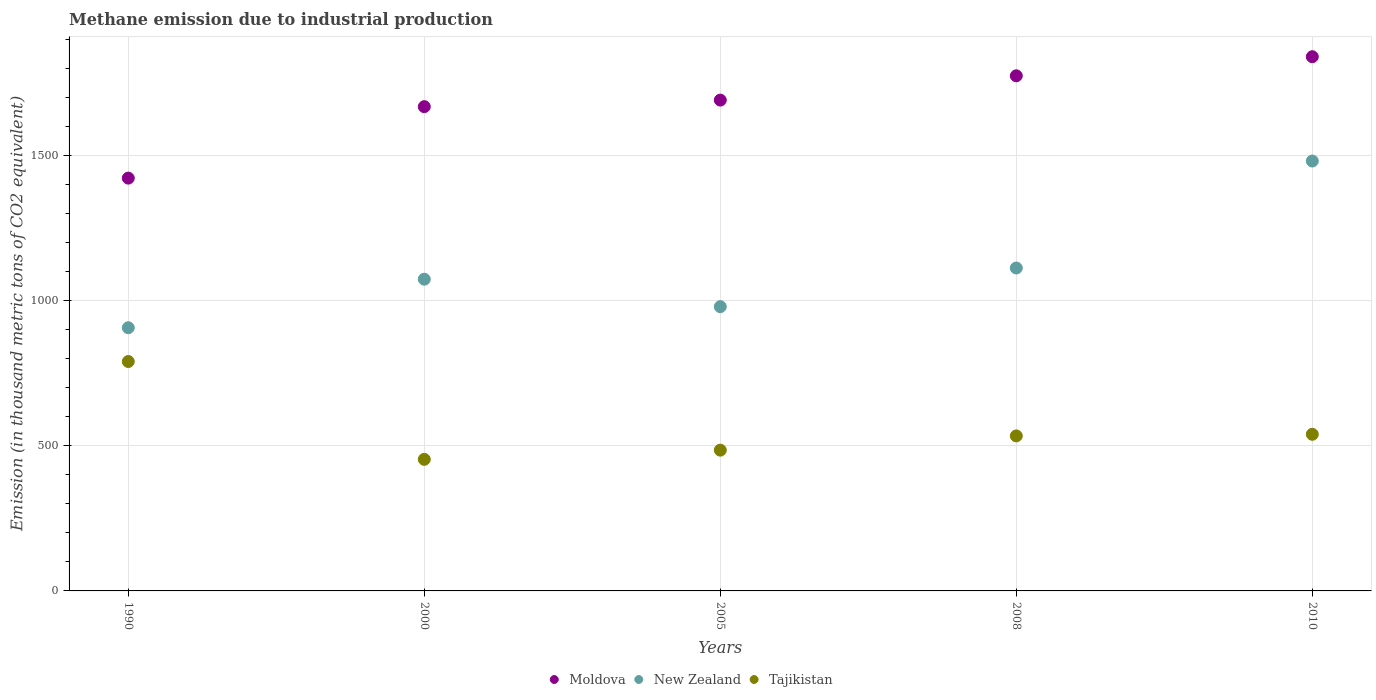How many different coloured dotlines are there?
Offer a very short reply. 3. Is the number of dotlines equal to the number of legend labels?
Keep it short and to the point. Yes. What is the amount of methane emitted in New Zealand in 1990?
Your response must be concise. 906.8. Across all years, what is the maximum amount of methane emitted in Moldova?
Keep it short and to the point. 1840.6. Across all years, what is the minimum amount of methane emitted in Tajikistan?
Offer a very short reply. 453.3. What is the total amount of methane emitted in Tajikistan in the graph?
Offer a very short reply. 2802.5. What is the difference between the amount of methane emitted in Tajikistan in 2005 and that in 2008?
Keep it short and to the point. -49.1. What is the difference between the amount of methane emitted in Moldova in 1990 and the amount of methane emitted in Tajikistan in 2010?
Your response must be concise. 882.6. What is the average amount of methane emitted in Moldova per year?
Keep it short and to the point. 1679.46. In the year 2005, what is the difference between the amount of methane emitted in Moldova and amount of methane emitted in Tajikistan?
Give a very brief answer. 1206.1. What is the ratio of the amount of methane emitted in Tajikistan in 2005 to that in 2010?
Provide a succinct answer. 0.9. Is the amount of methane emitted in Moldova in 2000 less than that in 2008?
Your response must be concise. Yes. Is the difference between the amount of methane emitted in Moldova in 2000 and 2010 greater than the difference between the amount of methane emitted in Tajikistan in 2000 and 2010?
Ensure brevity in your answer.  No. What is the difference between the highest and the second highest amount of methane emitted in New Zealand?
Your answer should be very brief. 368.6. What is the difference between the highest and the lowest amount of methane emitted in Moldova?
Ensure brevity in your answer.  418.3. Is the sum of the amount of methane emitted in New Zealand in 1990 and 2005 greater than the maximum amount of methane emitted in Tajikistan across all years?
Your answer should be very brief. Yes. Is the amount of methane emitted in New Zealand strictly greater than the amount of methane emitted in Moldova over the years?
Your answer should be compact. No. Is the amount of methane emitted in Moldova strictly less than the amount of methane emitted in New Zealand over the years?
Your answer should be compact. No. How many dotlines are there?
Make the answer very short. 3. How many years are there in the graph?
Keep it short and to the point. 5. What is the difference between two consecutive major ticks on the Y-axis?
Provide a succinct answer. 500. Where does the legend appear in the graph?
Offer a very short reply. Bottom center. How many legend labels are there?
Offer a very short reply. 3. How are the legend labels stacked?
Your answer should be compact. Horizontal. What is the title of the graph?
Your answer should be compact. Methane emission due to industrial production. Does "Libya" appear as one of the legend labels in the graph?
Your answer should be very brief. No. What is the label or title of the Y-axis?
Ensure brevity in your answer.  Emission (in thousand metric tons of CO2 equivalent). What is the Emission (in thousand metric tons of CO2 equivalent) in Moldova in 1990?
Your answer should be very brief. 1422.3. What is the Emission (in thousand metric tons of CO2 equivalent) of New Zealand in 1990?
Your answer should be very brief. 906.8. What is the Emission (in thousand metric tons of CO2 equivalent) in Tajikistan in 1990?
Give a very brief answer. 790.4. What is the Emission (in thousand metric tons of CO2 equivalent) of Moldova in 2000?
Offer a terse response. 1668.5. What is the Emission (in thousand metric tons of CO2 equivalent) in New Zealand in 2000?
Make the answer very short. 1074. What is the Emission (in thousand metric tons of CO2 equivalent) of Tajikistan in 2000?
Ensure brevity in your answer.  453.3. What is the Emission (in thousand metric tons of CO2 equivalent) of Moldova in 2005?
Your answer should be compact. 1691.1. What is the Emission (in thousand metric tons of CO2 equivalent) of New Zealand in 2005?
Make the answer very short. 979.4. What is the Emission (in thousand metric tons of CO2 equivalent) in Tajikistan in 2005?
Your response must be concise. 485. What is the Emission (in thousand metric tons of CO2 equivalent) of Moldova in 2008?
Provide a short and direct response. 1774.8. What is the Emission (in thousand metric tons of CO2 equivalent) in New Zealand in 2008?
Provide a succinct answer. 1112.6. What is the Emission (in thousand metric tons of CO2 equivalent) in Tajikistan in 2008?
Provide a succinct answer. 534.1. What is the Emission (in thousand metric tons of CO2 equivalent) of Moldova in 2010?
Give a very brief answer. 1840.6. What is the Emission (in thousand metric tons of CO2 equivalent) in New Zealand in 2010?
Offer a terse response. 1481.2. What is the Emission (in thousand metric tons of CO2 equivalent) in Tajikistan in 2010?
Make the answer very short. 539.7. Across all years, what is the maximum Emission (in thousand metric tons of CO2 equivalent) of Moldova?
Provide a succinct answer. 1840.6. Across all years, what is the maximum Emission (in thousand metric tons of CO2 equivalent) in New Zealand?
Your response must be concise. 1481.2. Across all years, what is the maximum Emission (in thousand metric tons of CO2 equivalent) in Tajikistan?
Provide a short and direct response. 790.4. Across all years, what is the minimum Emission (in thousand metric tons of CO2 equivalent) in Moldova?
Give a very brief answer. 1422.3. Across all years, what is the minimum Emission (in thousand metric tons of CO2 equivalent) of New Zealand?
Make the answer very short. 906.8. Across all years, what is the minimum Emission (in thousand metric tons of CO2 equivalent) of Tajikistan?
Your answer should be compact. 453.3. What is the total Emission (in thousand metric tons of CO2 equivalent) in Moldova in the graph?
Offer a terse response. 8397.3. What is the total Emission (in thousand metric tons of CO2 equivalent) of New Zealand in the graph?
Your response must be concise. 5554. What is the total Emission (in thousand metric tons of CO2 equivalent) in Tajikistan in the graph?
Keep it short and to the point. 2802.5. What is the difference between the Emission (in thousand metric tons of CO2 equivalent) of Moldova in 1990 and that in 2000?
Give a very brief answer. -246.2. What is the difference between the Emission (in thousand metric tons of CO2 equivalent) of New Zealand in 1990 and that in 2000?
Provide a succinct answer. -167.2. What is the difference between the Emission (in thousand metric tons of CO2 equivalent) of Tajikistan in 1990 and that in 2000?
Your answer should be very brief. 337.1. What is the difference between the Emission (in thousand metric tons of CO2 equivalent) in Moldova in 1990 and that in 2005?
Keep it short and to the point. -268.8. What is the difference between the Emission (in thousand metric tons of CO2 equivalent) in New Zealand in 1990 and that in 2005?
Keep it short and to the point. -72.6. What is the difference between the Emission (in thousand metric tons of CO2 equivalent) in Tajikistan in 1990 and that in 2005?
Make the answer very short. 305.4. What is the difference between the Emission (in thousand metric tons of CO2 equivalent) in Moldova in 1990 and that in 2008?
Ensure brevity in your answer.  -352.5. What is the difference between the Emission (in thousand metric tons of CO2 equivalent) of New Zealand in 1990 and that in 2008?
Offer a very short reply. -205.8. What is the difference between the Emission (in thousand metric tons of CO2 equivalent) in Tajikistan in 1990 and that in 2008?
Provide a succinct answer. 256.3. What is the difference between the Emission (in thousand metric tons of CO2 equivalent) in Moldova in 1990 and that in 2010?
Give a very brief answer. -418.3. What is the difference between the Emission (in thousand metric tons of CO2 equivalent) of New Zealand in 1990 and that in 2010?
Ensure brevity in your answer.  -574.4. What is the difference between the Emission (in thousand metric tons of CO2 equivalent) in Tajikistan in 1990 and that in 2010?
Offer a terse response. 250.7. What is the difference between the Emission (in thousand metric tons of CO2 equivalent) of Moldova in 2000 and that in 2005?
Ensure brevity in your answer.  -22.6. What is the difference between the Emission (in thousand metric tons of CO2 equivalent) in New Zealand in 2000 and that in 2005?
Your answer should be very brief. 94.6. What is the difference between the Emission (in thousand metric tons of CO2 equivalent) of Tajikistan in 2000 and that in 2005?
Offer a terse response. -31.7. What is the difference between the Emission (in thousand metric tons of CO2 equivalent) in Moldova in 2000 and that in 2008?
Give a very brief answer. -106.3. What is the difference between the Emission (in thousand metric tons of CO2 equivalent) of New Zealand in 2000 and that in 2008?
Provide a short and direct response. -38.6. What is the difference between the Emission (in thousand metric tons of CO2 equivalent) of Tajikistan in 2000 and that in 2008?
Your answer should be very brief. -80.8. What is the difference between the Emission (in thousand metric tons of CO2 equivalent) in Moldova in 2000 and that in 2010?
Ensure brevity in your answer.  -172.1. What is the difference between the Emission (in thousand metric tons of CO2 equivalent) in New Zealand in 2000 and that in 2010?
Your answer should be compact. -407.2. What is the difference between the Emission (in thousand metric tons of CO2 equivalent) in Tajikistan in 2000 and that in 2010?
Offer a terse response. -86.4. What is the difference between the Emission (in thousand metric tons of CO2 equivalent) in Moldova in 2005 and that in 2008?
Provide a succinct answer. -83.7. What is the difference between the Emission (in thousand metric tons of CO2 equivalent) in New Zealand in 2005 and that in 2008?
Keep it short and to the point. -133.2. What is the difference between the Emission (in thousand metric tons of CO2 equivalent) of Tajikistan in 2005 and that in 2008?
Your answer should be very brief. -49.1. What is the difference between the Emission (in thousand metric tons of CO2 equivalent) of Moldova in 2005 and that in 2010?
Keep it short and to the point. -149.5. What is the difference between the Emission (in thousand metric tons of CO2 equivalent) of New Zealand in 2005 and that in 2010?
Your answer should be very brief. -501.8. What is the difference between the Emission (in thousand metric tons of CO2 equivalent) of Tajikistan in 2005 and that in 2010?
Offer a terse response. -54.7. What is the difference between the Emission (in thousand metric tons of CO2 equivalent) in Moldova in 2008 and that in 2010?
Provide a short and direct response. -65.8. What is the difference between the Emission (in thousand metric tons of CO2 equivalent) in New Zealand in 2008 and that in 2010?
Your answer should be compact. -368.6. What is the difference between the Emission (in thousand metric tons of CO2 equivalent) in Moldova in 1990 and the Emission (in thousand metric tons of CO2 equivalent) in New Zealand in 2000?
Your response must be concise. 348.3. What is the difference between the Emission (in thousand metric tons of CO2 equivalent) of Moldova in 1990 and the Emission (in thousand metric tons of CO2 equivalent) of Tajikistan in 2000?
Give a very brief answer. 969. What is the difference between the Emission (in thousand metric tons of CO2 equivalent) in New Zealand in 1990 and the Emission (in thousand metric tons of CO2 equivalent) in Tajikistan in 2000?
Make the answer very short. 453.5. What is the difference between the Emission (in thousand metric tons of CO2 equivalent) in Moldova in 1990 and the Emission (in thousand metric tons of CO2 equivalent) in New Zealand in 2005?
Offer a very short reply. 442.9. What is the difference between the Emission (in thousand metric tons of CO2 equivalent) in Moldova in 1990 and the Emission (in thousand metric tons of CO2 equivalent) in Tajikistan in 2005?
Offer a terse response. 937.3. What is the difference between the Emission (in thousand metric tons of CO2 equivalent) of New Zealand in 1990 and the Emission (in thousand metric tons of CO2 equivalent) of Tajikistan in 2005?
Keep it short and to the point. 421.8. What is the difference between the Emission (in thousand metric tons of CO2 equivalent) of Moldova in 1990 and the Emission (in thousand metric tons of CO2 equivalent) of New Zealand in 2008?
Make the answer very short. 309.7. What is the difference between the Emission (in thousand metric tons of CO2 equivalent) of Moldova in 1990 and the Emission (in thousand metric tons of CO2 equivalent) of Tajikistan in 2008?
Give a very brief answer. 888.2. What is the difference between the Emission (in thousand metric tons of CO2 equivalent) of New Zealand in 1990 and the Emission (in thousand metric tons of CO2 equivalent) of Tajikistan in 2008?
Keep it short and to the point. 372.7. What is the difference between the Emission (in thousand metric tons of CO2 equivalent) of Moldova in 1990 and the Emission (in thousand metric tons of CO2 equivalent) of New Zealand in 2010?
Your response must be concise. -58.9. What is the difference between the Emission (in thousand metric tons of CO2 equivalent) of Moldova in 1990 and the Emission (in thousand metric tons of CO2 equivalent) of Tajikistan in 2010?
Offer a terse response. 882.6. What is the difference between the Emission (in thousand metric tons of CO2 equivalent) in New Zealand in 1990 and the Emission (in thousand metric tons of CO2 equivalent) in Tajikistan in 2010?
Offer a terse response. 367.1. What is the difference between the Emission (in thousand metric tons of CO2 equivalent) of Moldova in 2000 and the Emission (in thousand metric tons of CO2 equivalent) of New Zealand in 2005?
Provide a succinct answer. 689.1. What is the difference between the Emission (in thousand metric tons of CO2 equivalent) of Moldova in 2000 and the Emission (in thousand metric tons of CO2 equivalent) of Tajikistan in 2005?
Your answer should be very brief. 1183.5. What is the difference between the Emission (in thousand metric tons of CO2 equivalent) of New Zealand in 2000 and the Emission (in thousand metric tons of CO2 equivalent) of Tajikistan in 2005?
Keep it short and to the point. 589. What is the difference between the Emission (in thousand metric tons of CO2 equivalent) of Moldova in 2000 and the Emission (in thousand metric tons of CO2 equivalent) of New Zealand in 2008?
Ensure brevity in your answer.  555.9. What is the difference between the Emission (in thousand metric tons of CO2 equivalent) of Moldova in 2000 and the Emission (in thousand metric tons of CO2 equivalent) of Tajikistan in 2008?
Your response must be concise. 1134.4. What is the difference between the Emission (in thousand metric tons of CO2 equivalent) of New Zealand in 2000 and the Emission (in thousand metric tons of CO2 equivalent) of Tajikistan in 2008?
Offer a very short reply. 539.9. What is the difference between the Emission (in thousand metric tons of CO2 equivalent) in Moldova in 2000 and the Emission (in thousand metric tons of CO2 equivalent) in New Zealand in 2010?
Your answer should be compact. 187.3. What is the difference between the Emission (in thousand metric tons of CO2 equivalent) in Moldova in 2000 and the Emission (in thousand metric tons of CO2 equivalent) in Tajikistan in 2010?
Make the answer very short. 1128.8. What is the difference between the Emission (in thousand metric tons of CO2 equivalent) of New Zealand in 2000 and the Emission (in thousand metric tons of CO2 equivalent) of Tajikistan in 2010?
Offer a very short reply. 534.3. What is the difference between the Emission (in thousand metric tons of CO2 equivalent) of Moldova in 2005 and the Emission (in thousand metric tons of CO2 equivalent) of New Zealand in 2008?
Offer a terse response. 578.5. What is the difference between the Emission (in thousand metric tons of CO2 equivalent) in Moldova in 2005 and the Emission (in thousand metric tons of CO2 equivalent) in Tajikistan in 2008?
Give a very brief answer. 1157. What is the difference between the Emission (in thousand metric tons of CO2 equivalent) in New Zealand in 2005 and the Emission (in thousand metric tons of CO2 equivalent) in Tajikistan in 2008?
Ensure brevity in your answer.  445.3. What is the difference between the Emission (in thousand metric tons of CO2 equivalent) of Moldova in 2005 and the Emission (in thousand metric tons of CO2 equivalent) of New Zealand in 2010?
Provide a succinct answer. 209.9. What is the difference between the Emission (in thousand metric tons of CO2 equivalent) of Moldova in 2005 and the Emission (in thousand metric tons of CO2 equivalent) of Tajikistan in 2010?
Provide a succinct answer. 1151.4. What is the difference between the Emission (in thousand metric tons of CO2 equivalent) of New Zealand in 2005 and the Emission (in thousand metric tons of CO2 equivalent) of Tajikistan in 2010?
Your response must be concise. 439.7. What is the difference between the Emission (in thousand metric tons of CO2 equivalent) in Moldova in 2008 and the Emission (in thousand metric tons of CO2 equivalent) in New Zealand in 2010?
Provide a succinct answer. 293.6. What is the difference between the Emission (in thousand metric tons of CO2 equivalent) of Moldova in 2008 and the Emission (in thousand metric tons of CO2 equivalent) of Tajikistan in 2010?
Your answer should be compact. 1235.1. What is the difference between the Emission (in thousand metric tons of CO2 equivalent) in New Zealand in 2008 and the Emission (in thousand metric tons of CO2 equivalent) in Tajikistan in 2010?
Provide a succinct answer. 572.9. What is the average Emission (in thousand metric tons of CO2 equivalent) in Moldova per year?
Your response must be concise. 1679.46. What is the average Emission (in thousand metric tons of CO2 equivalent) of New Zealand per year?
Keep it short and to the point. 1110.8. What is the average Emission (in thousand metric tons of CO2 equivalent) of Tajikistan per year?
Offer a terse response. 560.5. In the year 1990, what is the difference between the Emission (in thousand metric tons of CO2 equivalent) of Moldova and Emission (in thousand metric tons of CO2 equivalent) of New Zealand?
Keep it short and to the point. 515.5. In the year 1990, what is the difference between the Emission (in thousand metric tons of CO2 equivalent) of Moldova and Emission (in thousand metric tons of CO2 equivalent) of Tajikistan?
Offer a terse response. 631.9. In the year 1990, what is the difference between the Emission (in thousand metric tons of CO2 equivalent) in New Zealand and Emission (in thousand metric tons of CO2 equivalent) in Tajikistan?
Provide a short and direct response. 116.4. In the year 2000, what is the difference between the Emission (in thousand metric tons of CO2 equivalent) of Moldova and Emission (in thousand metric tons of CO2 equivalent) of New Zealand?
Give a very brief answer. 594.5. In the year 2000, what is the difference between the Emission (in thousand metric tons of CO2 equivalent) of Moldova and Emission (in thousand metric tons of CO2 equivalent) of Tajikistan?
Give a very brief answer. 1215.2. In the year 2000, what is the difference between the Emission (in thousand metric tons of CO2 equivalent) in New Zealand and Emission (in thousand metric tons of CO2 equivalent) in Tajikistan?
Provide a succinct answer. 620.7. In the year 2005, what is the difference between the Emission (in thousand metric tons of CO2 equivalent) of Moldova and Emission (in thousand metric tons of CO2 equivalent) of New Zealand?
Give a very brief answer. 711.7. In the year 2005, what is the difference between the Emission (in thousand metric tons of CO2 equivalent) in Moldova and Emission (in thousand metric tons of CO2 equivalent) in Tajikistan?
Your response must be concise. 1206.1. In the year 2005, what is the difference between the Emission (in thousand metric tons of CO2 equivalent) of New Zealand and Emission (in thousand metric tons of CO2 equivalent) of Tajikistan?
Offer a very short reply. 494.4. In the year 2008, what is the difference between the Emission (in thousand metric tons of CO2 equivalent) in Moldova and Emission (in thousand metric tons of CO2 equivalent) in New Zealand?
Offer a very short reply. 662.2. In the year 2008, what is the difference between the Emission (in thousand metric tons of CO2 equivalent) of Moldova and Emission (in thousand metric tons of CO2 equivalent) of Tajikistan?
Provide a short and direct response. 1240.7. In the year 2008, what is the difference between the Emission (in thousand metric tons of CO2 equivalent) of New Zealand and Emission (in thousand metric tons of CO2 equivalent) of Tajikistan?
Give a very brief answer. 578.5. In the year 2010, what is the difference between the Emission (in thousand metric tons of CO2 equivalent) of Moldova and Emission (in thousand metric tons of CO2 equivalent) of New Zealand?
Make the answer very short. 359.4. In the year 2010, what is the difference between the Emission (in thousand metric tons of CO2 equivalent) of Moldova and Emission (in thousand metric tons of CO2 equivalent) of Tajikistan?
Your answer should be compact. 1300.9. In the year 2010, what is the difference between the Emission (in thousand metric tons of CO2 equivalent) of New Zealand and Emission (in thousand metric tons of CO2 equivalent) of Tajikistan?
Offer a very short reply. 941.5. What is the ratio of the Emission (in thousand metric tons of CO2 equivalent) in Moldova in 1990 to that in 2000?
Give a very brief answer. 0.85. What is the ratio of the Emission (in thousand metric tons of CO2 equivalent) of New Zealand in 1990 to that in 2000?
Your answer should be very brief. 0.84. What is the ratio of the Emission (in thousand metric tons of CO2 equivalent) in Tajikistan in 1990 to that in 2000?
Keep it short and to the point. 1.74. What is the ratio of the Emission (in thousand metric tons of CO2 equivalent) in Moldova in 1990 to that in 2005?
Ensure brevity in your answer.  0.84. What is the ratio of the Emission (in thousand metric tons of CO2 equivalent) of New Zealand in 1990 to that in 2005?
Make the answer very short. 0.93. What is the ratio of the Emission (in thousand metric tons of CO2 equivalent) in Tajikistan in 1990 to that in 2005?
Provide a short and direct response. 1.63. What is the ratio of the Emission (in thousand metric tons of CO2 equivalent) of Moldova in 1990 to that in 2008?
Your response must be concise. 0.8. What is the ratio of the Emission (in thousand metric tons of CO2 equivalent) of New Zealand in 1990 to that in 2008?
Give a very brief answer. 0.81. What is the ratio of the Emission (in thousand metric tons of CO2 equivalent) of Tajikistan in 1990 to that in 2008?
Make the answer very short. 1.48. What is the ratio of the Emission (in thousand metric tons of CO2 equivalent) in Moldova in 1990 to that in 2010?
Ensure brevity in your answer.  0.77. What is the ratio of the Emission (in thousand metric tons of CO2 equivalent) in New Zealand in 1990 to that in 2010?
Give a very brief answer. 0.61. What is the ratio of the Emission (in thousand metric tons of CO2 equivalent) in Tajikistan in 1990 to that in 2010?
Your answer should be compact. 1.46. What is the ratio of the Emission (in thousand metric tons of CO2 equivalent) in Moldova in 2000 to that in 2005?
Provide a short and direct response. 0.99. What is the ratio of the Emission (in thousand metric tons of CO2 equivalent) of New Zealand in 2000 to that in 2005?
Your answer should be compact. 1.1. What is the ratio of the Emission (in thousand metric tons of CO2 equivalent) of Tajikistan in 2000 to that in 2005?
Make the answer very short. 0.93. What is the ratio of the Emission (in thousand metric tons of CO2 equivalent) in Moldova in 2000 to that in 2008?
Ensure brevity in your answer.  0.94. What is the ratio of the Emission (in thousand metric tons of CO2 equivalent) in New Zealand in 2000 to that in 2008?
Provide a succinct answer. 0.97. What is the ratio of the Emission (in thousand metric tons of CO2 equivalent) in Tajikistan in 2000 to that in 2008?
Provide a short and direct response. 0.85. What is the ratio of the Emission (in thousand metric tons of CO2 equivalent) of Moldova in 2000 to that in 2010?
Your answer should be compact. 0.91. What is the ratio of the Emission (in thousand metric tons of CO2 equivalent) of New Zealand in 2000 to that in 2010?
Your response must be concise. 0.73. What is the ratio of the Emission (in thousand metric tons of CO2 equivalent) of Tajikistan in 2000 to that in 2010?
Provide a succinct answer. 0.84. What is the ratio of the Emission (in thousand metric tons of CO2 equivalent) in Moldova in 2005 to that in 2008?
Give a very brief answer. 0.95. What is the ratio of the Emission (in thousand metric tons of CO2 equivalent) in New Zealand in 2005 to that in 2008?
Give a very brief answer. 0.88. What is the ratio of the Emission (in thousand metric tons of CO2 equivalent) in Tajikistan in 2005 to that in 2008?
Your response must be concise. 0.91. What is the ratio of the Emission (in thousand metric tons of CO2 equivalent) of Moldova in 2005 to that in 2010?
Keep it short and to the point. 0.92. What is the ratio of the Emission (in thousand metric tons of CO2 equivalent) of New Zealand in 2005 to that in 2010?
Your answer should be compact. 0.66. What is the ratio of the Emission (in thousand metric tons of CO2 equivalent) in Tajikistan in 2005 to that in 2010?
Give a very brief answer. 0.9. What is the ratio of the Emission (in thousand metric tons of CO2 equivalent) in Moldova in 2008 to that in 2010?
Provide a short and direct response. 0.96. What is the ratio of the Emission (in thousand metric tons of CO2 equivalent) in New Zealand in 2008 to that in 2010?
Keep it short and to the point. 0.75. What is the difference between the highest and the second highest Emission (in thousand metric tons of CO2 equivalent) of Moldova?
Give a very brief answer. 65.8. What is the difference between the highest and the second highest Emission (in thousand metric tons of CO2 equivalent) in New Zealand?
Offer a very short reply. 368.6. What is the difference between the highest and the second highest Emission (in thousand metric tons of CO2 equivalent) in Tajikistan?
Make the answer very short. 250.7. What is the difference between the highest and the lowest Emission (in thousand metric tons of CO2 equivalent) of Moldova?
Offer a terse response. 418.3. What is the difference between the highest and the lowest Emission (in thousand metric tons of CO2 equivalent) in New Zealand?
Your answer should be compact. 574.4. What is the difference between the highest and the lowest Emission (in thousand metric tons of CO2 equivalent) of Tajikistan?
Give a very brief answer. 337.1. 